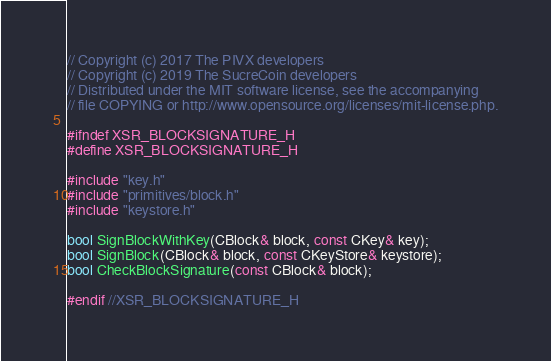<code> <loc_0><loc_0><loc_500><loc_500><_C_>// Copyright (c) 2017 The PIVX developers
// Copyright (c) 2019 The SucreCoin developers
// Distributed under the MIT software license, see the accompanying
// file COPYING or http://www.opensource.org/licenses/mit-license.php.

#ifndef XSR_BLOCKSIGNATURE_H
#define XSR_BLOCKSIGNATURE_H

#include "key.h"
#include "primitives/block.h"
#include "keystore.h"

bool SignBlockWithKey(CBlock& block, const CKey& key);
bool SignBlock(CBlock& block, const CKeyStore& keystore);
bool CheckBlockSignature(const CBlock& block);

#endif //XSR_BLOCKSIGNATURE_H
</code> 